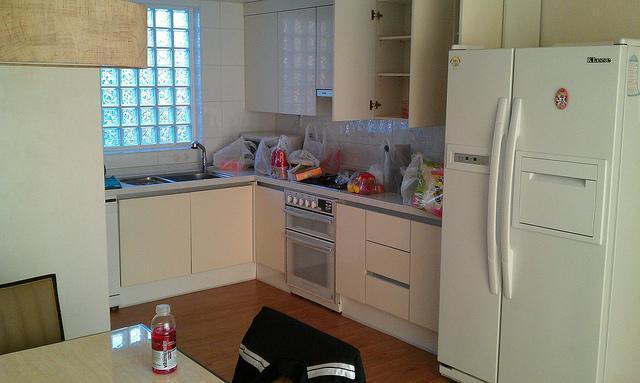How many cabinet doors are open in this picture?
Give a very brief answer. 3. How many magnets are on the refrigerator?
Give a very brief answer. 1. How many chairs can be seen?
Give a very brief answer. 2. How many ovens are there?
Give a very brief answer. 1. How many people are standing between the elephant trunks?
Give a very brief answer. 0. 